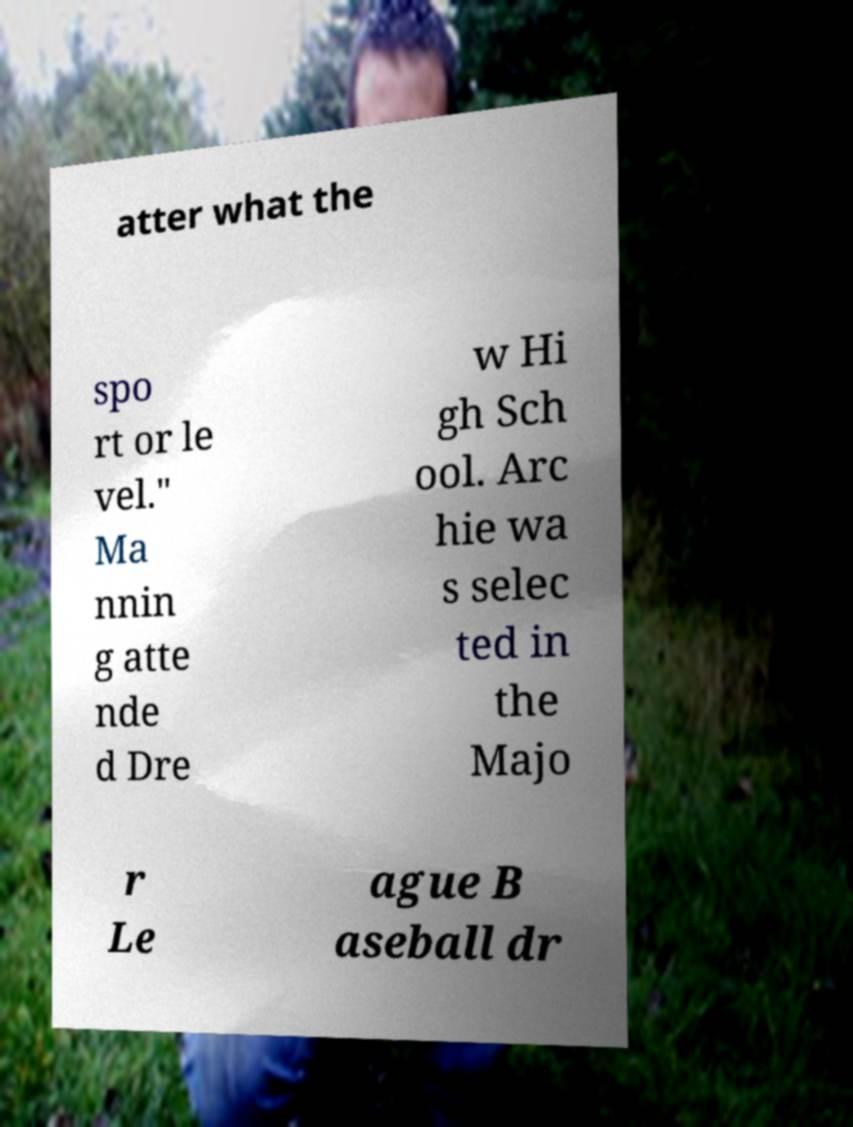For documentation purposes, I need the text within this image transcribed. Could you provide that? atter what the spo rt or le vel." Ma nnin g atte nde d Dre w Hi gh Sch ool. Arc hie wa s selec ted in the Majo r Le ague B aseball dr 